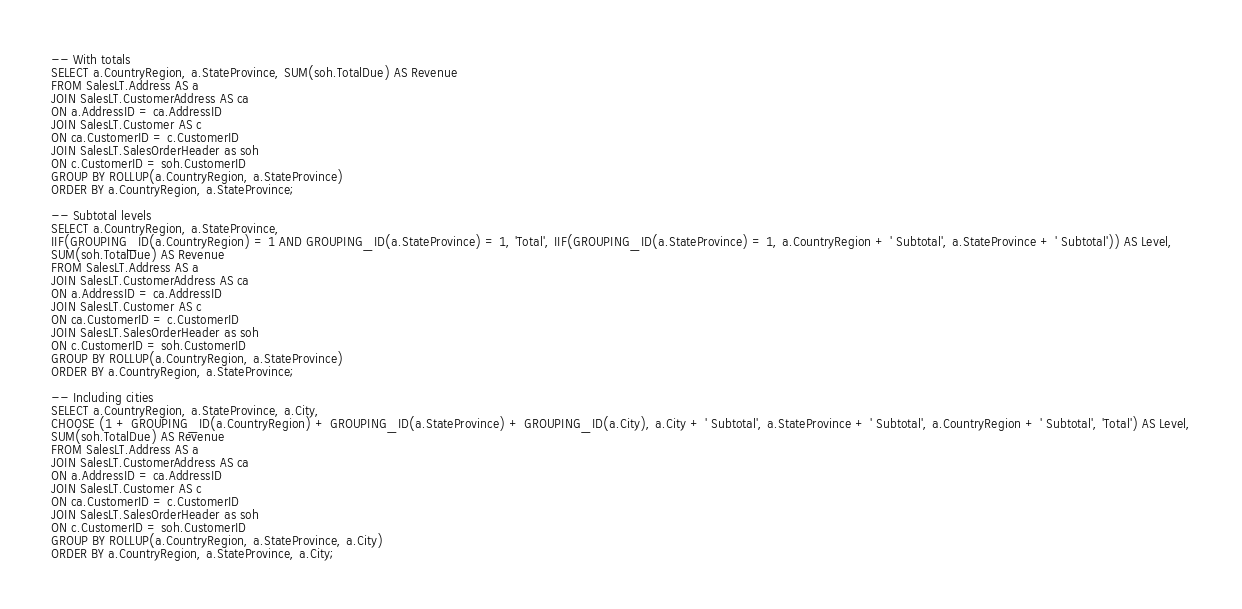Convert code to text. <code><loc_0><loc_0><loc_500><loc_500><_SQL_>
-- With totals
SELECT a.CountryRegion, a.StateProvince, SUM(soh.TotalDue) AS Revenue
FROM SalesLT.Address AS a
JOIN SalesLT.CustomerAddress AS ca
ON a.AddressID = ca.AddressID
JOIN SalesLT.Customer AS c
ON ca.CustomerID = c.CustomerID
JOIN SalesLT.SalesOrderHeader as soh
ON c.CustomerID = soh.CustomerID
GROUP BY ROLLUP(a.CountryRegion, a.StateProvince)
ORDER BY a.CountryRegion, a.StateProvince;

-- Subtotal levels
SELECT a.CountryRegion, a.StateProvince,
IIF(GROUPING_ID(a.CountryRegion) = 1 AND GROUPING_ID(a.StateProvince) = 1, 'Total', IIF(GROUPING_ID(a.StateProvince) = 1, a.CountryRegion + ' Subtotal', a.StateProvince + ' Subtotal')) AS Level,
SUM(soh.TotalDue) AS Revenue
FROM SalesLT.Address AS a
JOIN SalesLT.CustomerAddress AS ca
ON a.AddressID = ca.AddressID
JOIN SalesLT.Customer AS c
ON ca.CustomerID = c.CustomerID
JOIN SalesLT.SalesOrderHeader as soh
ON c.CustomerID = soh.CustomerID
GROUP BY ROLLUP(a.CountryRegion, a.StateProvince)
ORDER BY a.CountryRegion, a.StateProvince;

-- Including cities
SELECT a.CountryRegion, a.StateProvince, a.City,
CHOOSE (1 + GROUPING_ID(a.CountryRegion) + GROUPING_ID(a.StateProvince) + GROUPING_ID(a.City), a.City + ' Subtotal', a.StateProvince + ' Subtotal', a.CountryRegion + ' Subtotal', 'Total') AS Level,
SUM(soh.TotalDue) AS Revenue
FROM SalesLT.Address AS a
JOIN SalesLT.CustomerAddress AS ca
ON a.AddressID = ca.AddressID
JOIN SalesLT.Customer AS c
ON ca.CustomerID = c.CustomerID
JOIN SalesLT.SalesOrderHeader as soh
ON c.CustomerID = soh.CustomerID
GROUP BY ROLLUP(a.CountryRegion, a.StateProvince, a.City)
ORDER BY a.CountryRegion, a.StateProvince, a.City;</code> 